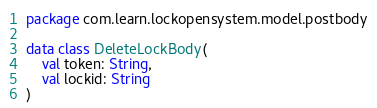Convert code to text. <code><loc_0><loc_0><loc_500><loc_500><_Kotlin_>package com.learn.lockopensystem.model.postbody

data class DeleteLockBody(
    val token: String,
    val lockid: String
)</code> 